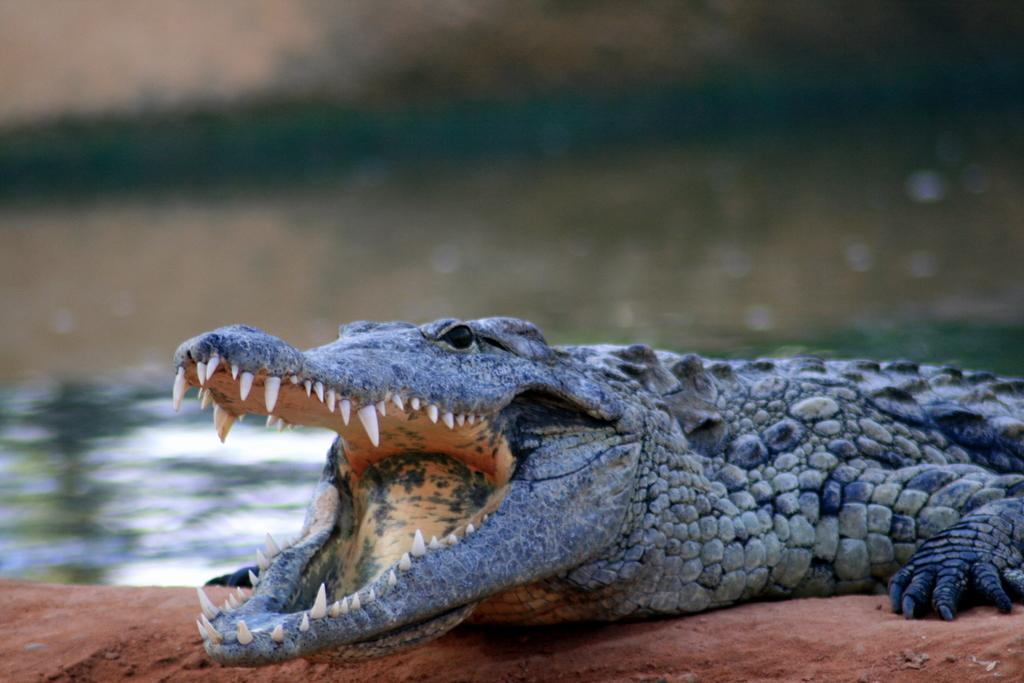What animal is present in the image? There is a crocodile in the image. Where is the crocodile located? The crocodile is on a path. Can you describe the background of the image? The background of the image is blurred. How many children are playing with the pin and bread in the image? There are no children, pins, or bread present in the image; it features a crocodile on a path with a blurred background. 